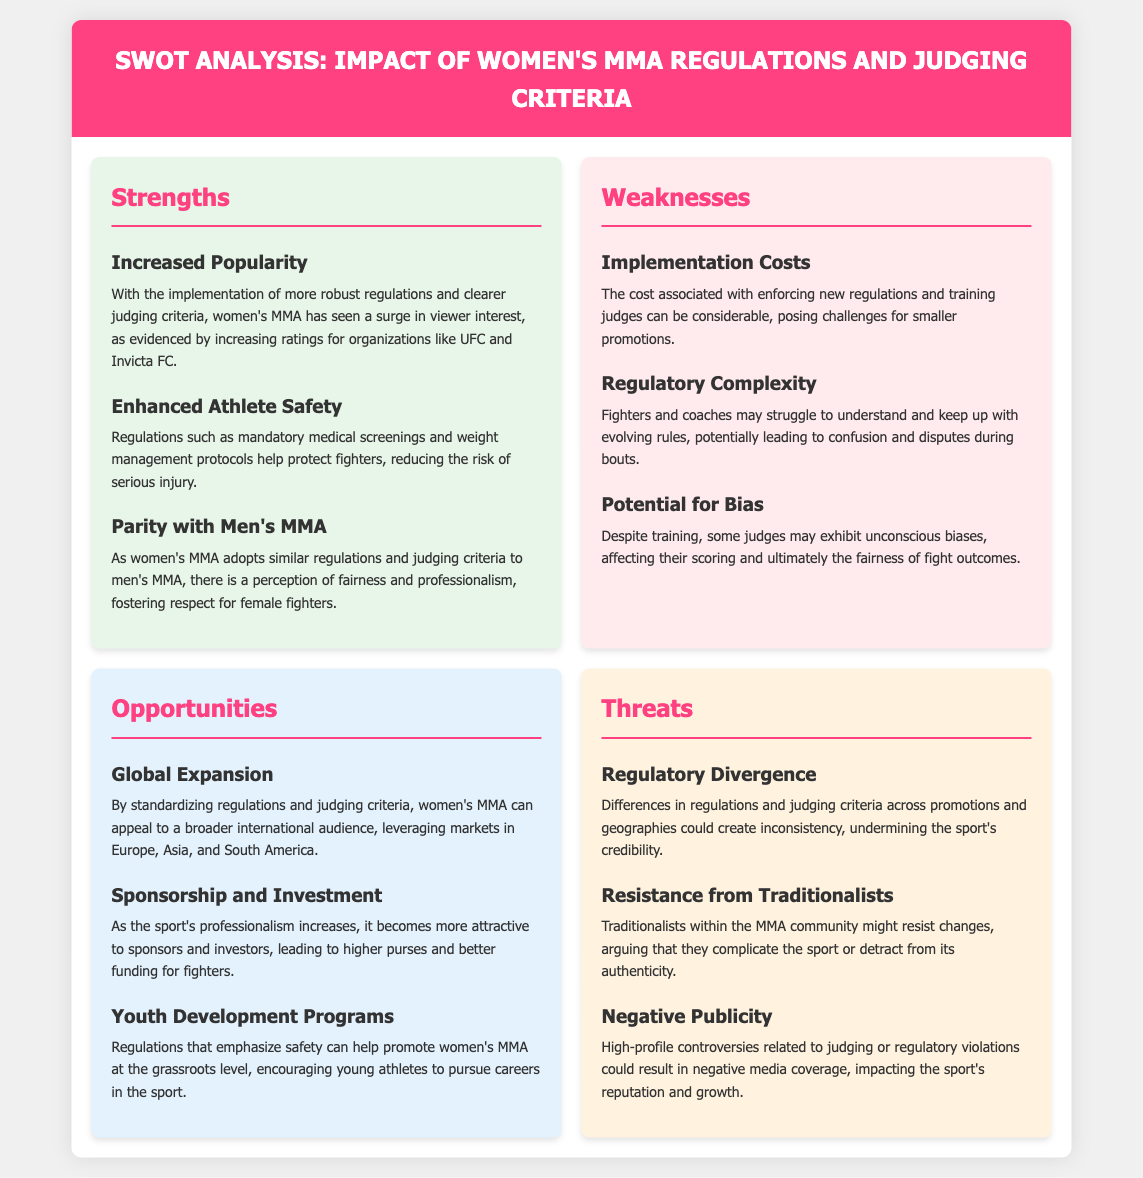What is one of the strengths of women's MMA regulations? The document mentions increased popularity as a strength, noting a surge in viewer interest with clearer judging criteria.
Answer: Increased popularity What is a weakness associated with implementing new regulations in women's MMA? The document highlights implementation costs as a weakness, indicating challenges for smaller promotions.
Answer: Implementation costs What opportunity is mentioned regarding the global reach of women's MMA? Global expansion is noted in the document as an opportunity to appeal to a broader international audience.
Answer: Global expansion What threat is associated with differences in regulations across promotions? The document discusses regulatory divergence as a threat, which could undermine the sport's credibility.
Answer: Regulatory divergence What is one of the enhanced safety measures for fighters? The document lists mandatory medical screenings as an enhancement for athlete safety in women's MMA.
Answer: Mandatory medical screenings What is a potential issue judges might face according to the weaknesses section? The document notes potential bias as a weakness, where some judges may exhibit unconscious biases.
Answer: Potential for bias What effect do the new regulations have on sponsorship and investment? The document indicates that increasing professionalism makes women's MMA more attractive to sponsors.
Answer: Sponsorship and investment What is one of the consequences of high-profile controversies in women's MMA? According to the threats section, negative publicity can impact the sport's reputation and growth.
Answer: Negative publicity 